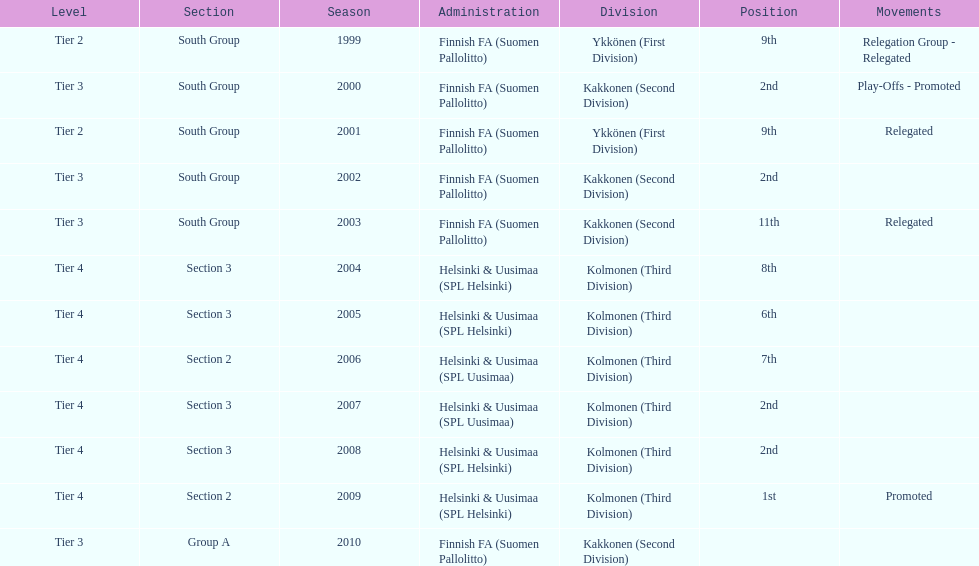How many times were they in tier 3? 4. 